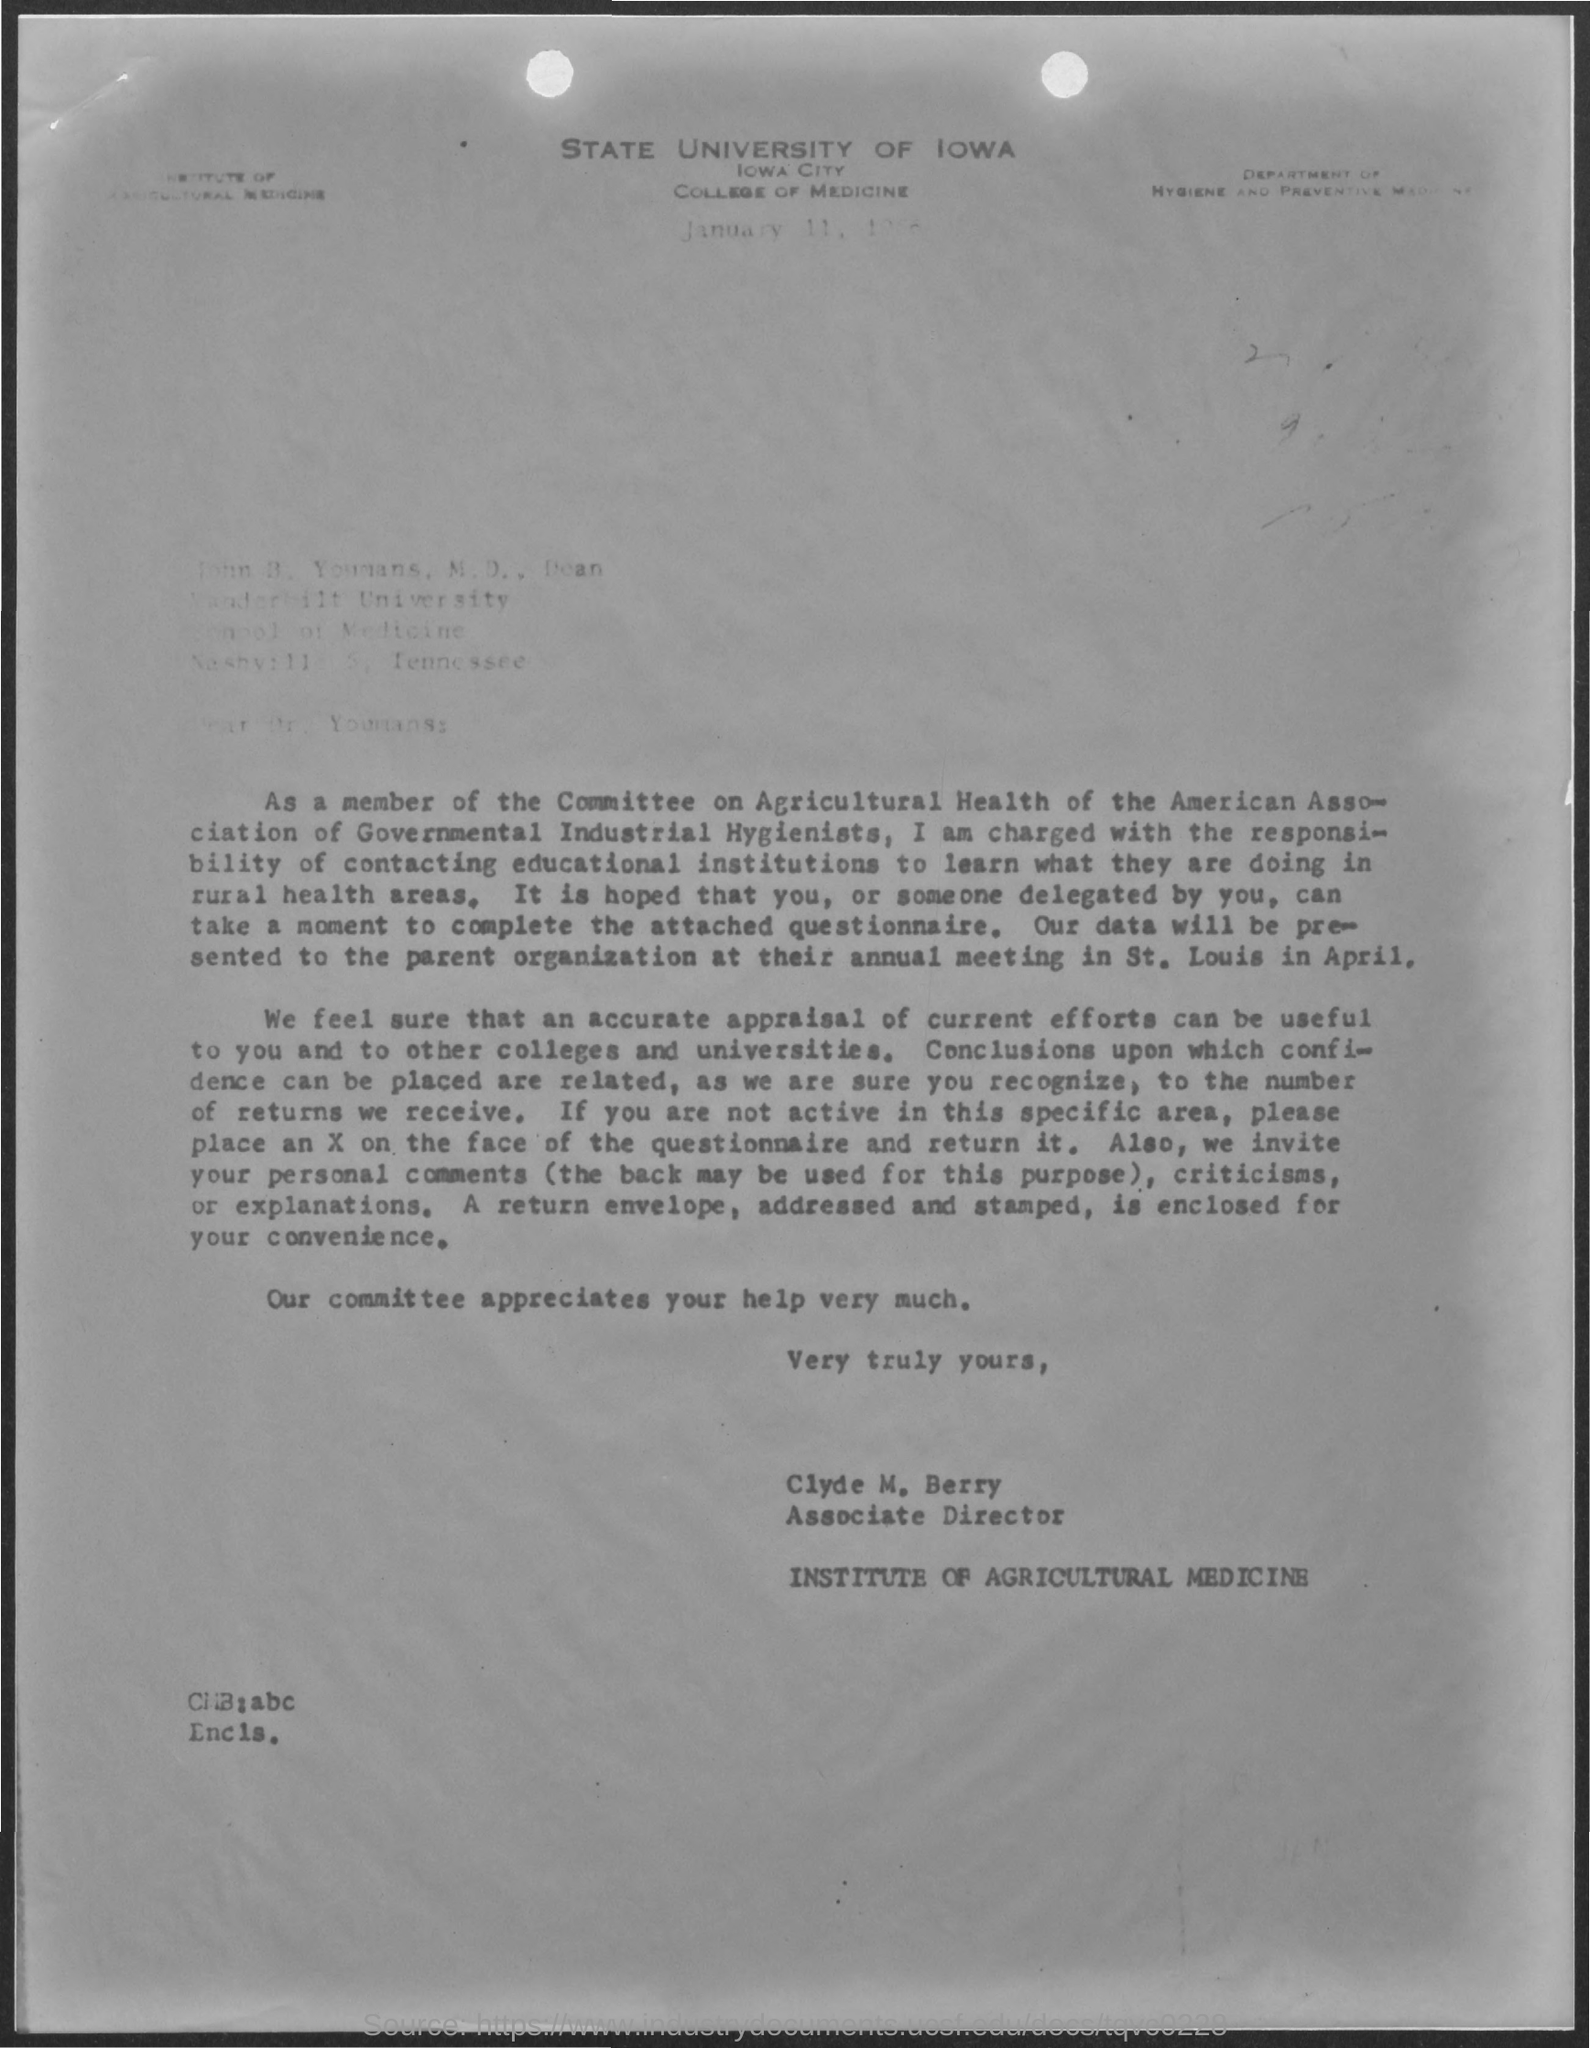Mention a couple of crucial points in this snapshot. The State University of Iowa is mentioned. Clyde holds the designation of Associate Director. The sender is CLYDE M. BERRY. Clyde is a part of the Institute of Agricultural Medicine. 